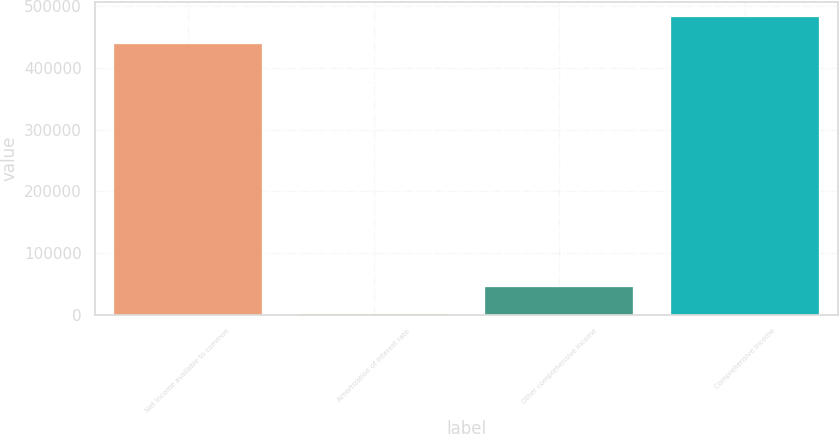<chart> <loc_0><loc_0><loc_500><loc_500><bar_chart><fcel>Net income available to common<fcel>Amortization of interest rate<fcel>Other comprehensive income<fcel>Comprehensive income<nl><fcel>438292<fcel>698<fcel>45133<fcel>482727<nl></chart> 